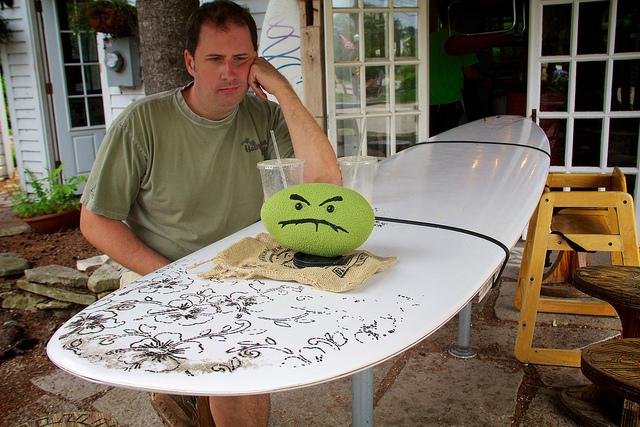What is the green thing?
Keep it brief. Football. Does the green ball look happy?
Short answer required. No. What is the green ball sitting on?
Be succinct. Surfboard. 